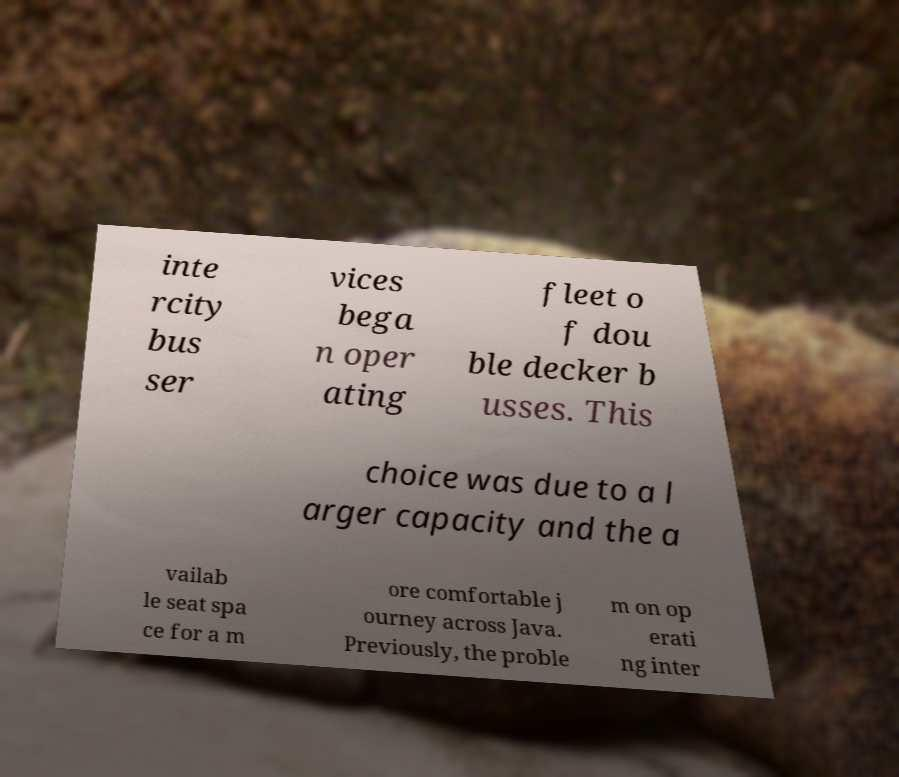Could you assist in decoding the text presented in this image and type it out clearly? inte rcity bus ser vices bega n oper ating fleet o f dou ble decker b usses. This choice was due to a l arger capacity and the a vailab le seat spa ce for a m ore comfortable j ourney across Java. Previously, the proble m on op erati ng inter 